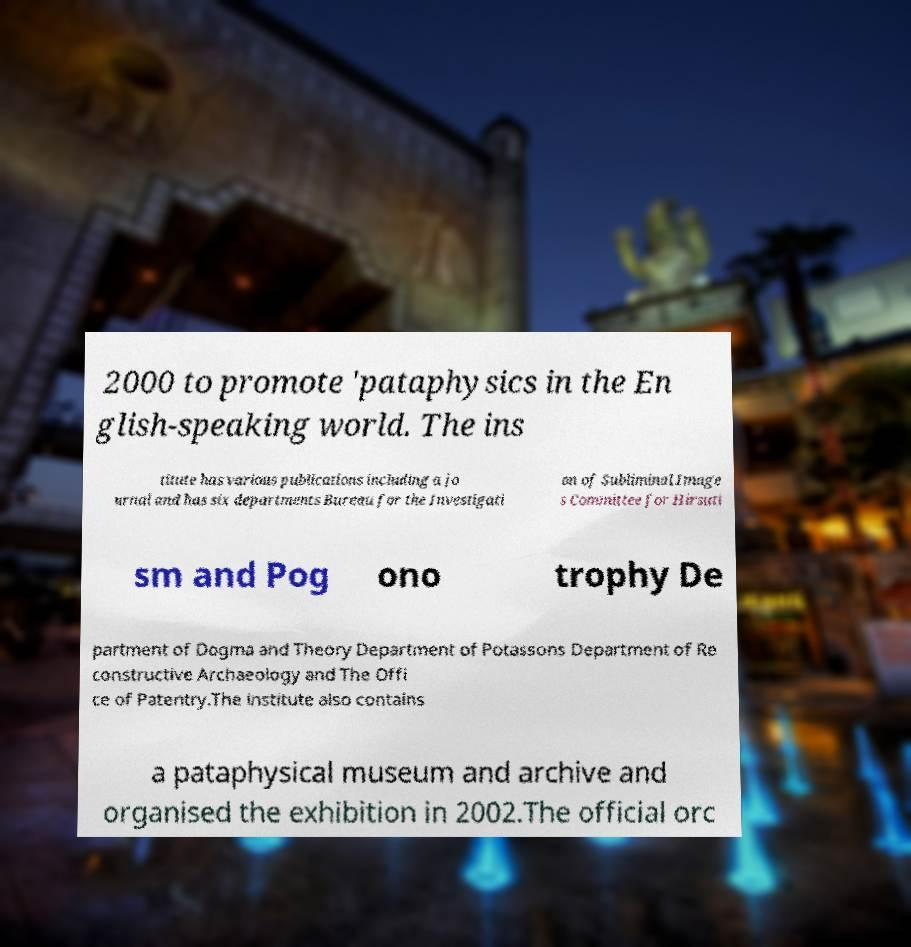For documentation purposes, I need the text within this image transcribed. Could you provide that? 2000 to promote 'pataphysics in the En glish-speaking world. The ins titute has various publications including a jo urnal and has six departments Bureau for the Investigati on of Subliminal Image s Committee for Hirsuti sm and Pog ono trophy De partment of Dogma and Theory Department of Potassons Department of Re constructive Archaeology and The Offi ce of Patentry.The institute also contains a pataphysical museum and archive and organised the exhibition in 2002.The official orc 